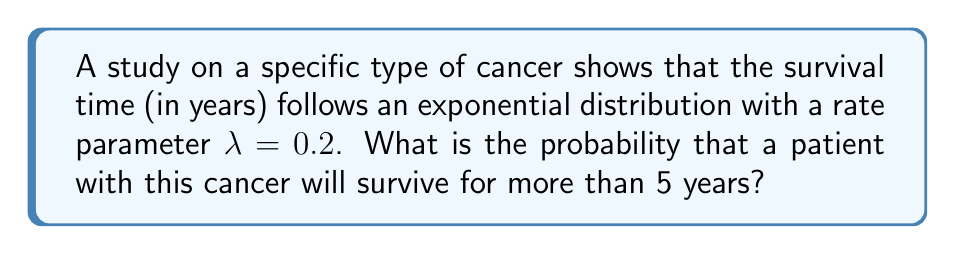Help me with this question. Let's approach this step-by-step:

1) For an exponential distribution with rate parameter $\lambda$, the probability density function is given by:

   $f(t) = \lambda e^{-\lambda t}$

2) The cumulative distribution function (CDF) is:

   $F(t) = 1 - e^{-\lambda t}$

3) We want to find the probability of surviving more than 5 years. This is the complement of the probability of surviving less than or equal to 5 years. In mathematical terms:

   $P(T > 5) = 1 - P(T \leq 5) = 1 - F(5)$

4) Substituting the values:

   $P(T > 5) = 1 - (1 - e^{-0.2 \cdot 5})$

5) Simplify:

   $P(T > 5) = e^{-0.2 \cdot 5} = e^{-1}$

6) Calculate the final value:

   $P(T > 5) = e^{-1} \approx 0.3679$

Therefore, the probability that a patient with this cancer will survive for more than 5 years is approximately 0.3679 or about 36.79%.
Answer: $e^{-1} \approx 0.3679$ 